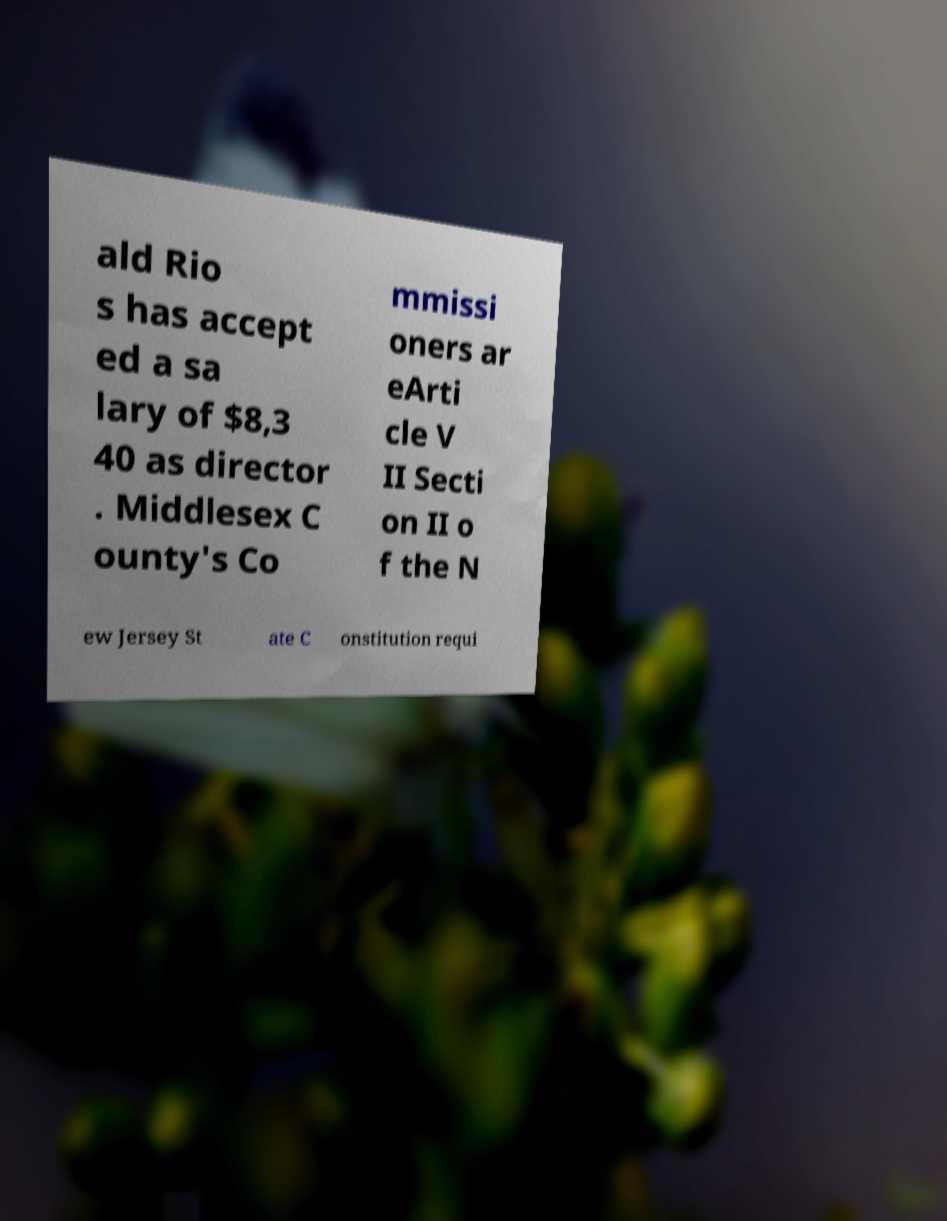Can you read and provide the text displayed in the image?This photo seems to have some interesting text. Can you extract and type it out for me? ald Rio s has accept ed a sa lary of $8,3 40 as director . Middlesex C ounty's Co mmissi oners ar eArti cle V II Secti on II o f the N ew Jersey St ate C onstitution requi 